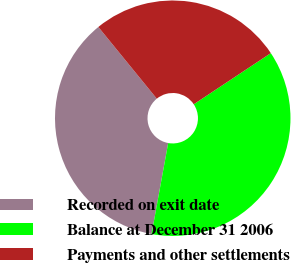Convert chart. <chart><loc_0><loc_0><loc_500><loc_500><pie_chart><fcel>Recorded on exit date<fcel>Balance at December 31 2006<fcel>Payments and other settlements<nl><fcel>36.24%<fcel>37.21%<fcel>26.56%<nl></chart> 